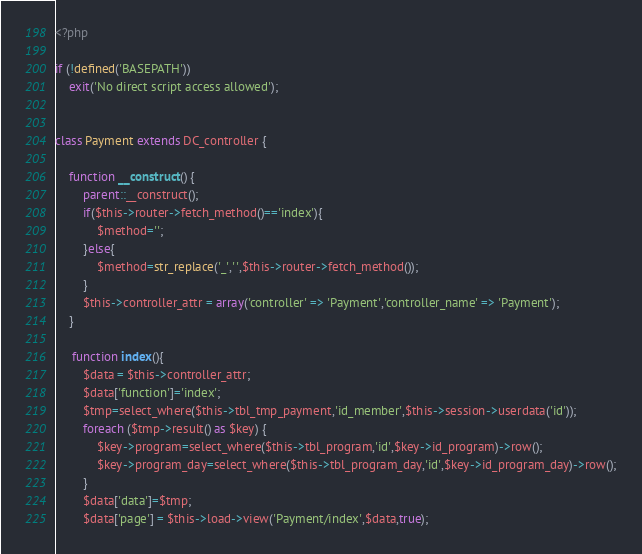Convert code to text. <code><loc_0><loc_0><loc_500><loc_500><_PHP_><?php

if (!defined('BASEPATH'))
	exit('No direct script access allowed');


class Payment extends DC_controller {

	function __construct() {
		parent::__construct();
		if($this->router->fetch_method()=='index'){
			$method='';
		}else{
			$method=str_replace('_',' ',$this->router->fetch_method());
		}
		$this->controller_attr = array('controller' => 'Payment','controller_name' => 'Payment');
	}
	
	 function index(){
		$data = $this->controller_attr;
		$data['function']='index';
		$tmp=select_where($this->tbl_tmp_payment,'id_member',$this->session->userdata('id'));
		foreach ($tmp->result() as $key) {
			$key->program=select_where($this->tbl_program,'id',$key->id_program)->row();
			$key->program_day=select_where($this->tbl_program_day,'id',$key->id_program_day)->row();
		}
		$data['data']=$tmp;
		$data['page'] = $this->load->view('Payment/index',$data,true);</code> 